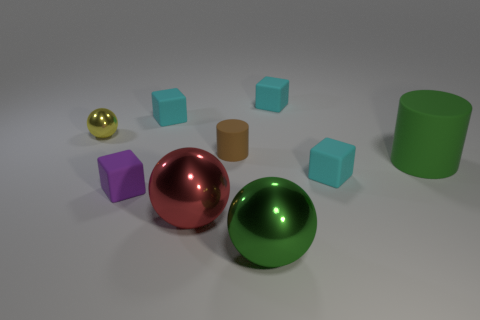What shape is the metal object that is both to the left of the tiny brown matte cylinder and on the right side of the small yellow metallic ball?
Make the answer very short. Sphere. Do the big shiny sphere behind the big green metallic ball and the small ball have the same color?
Keep it short and to the point. No. There is a large shiny thing left of the small cylinder; is its shape the same as the cyan thing in front of the big matte object?
Your answer should be very brief. No. What is the size of the cyan rubber thing that is in front of the big rubber cylinder?
Your response must be concise. Small. There is a matte object that is in front of the tiny cyan rubber thing that is in front of the tiny yellow metallic sphere; how big is it?
Keep it short and to the point. Small. Are there more large blue balls than cyan things?
Your response must be concise. No. Are there more tiny brown rubber things that are behind the large green cylinder than tiny purple rubber blocks that are behind the small brown cylinder?
Offer a terse response. Yes. There is a cyan matte cube that is on the right side of the small cylinder and behind the large green matte thing; what is its size?
Your answer should be very brief. Small. What number of cyan objects are the same size as the purple object?
Keep it short and to the point. 3. There is a large thing that is the same color as the big cylinder; what is it made of?
Your answer should be compact. Metal. 